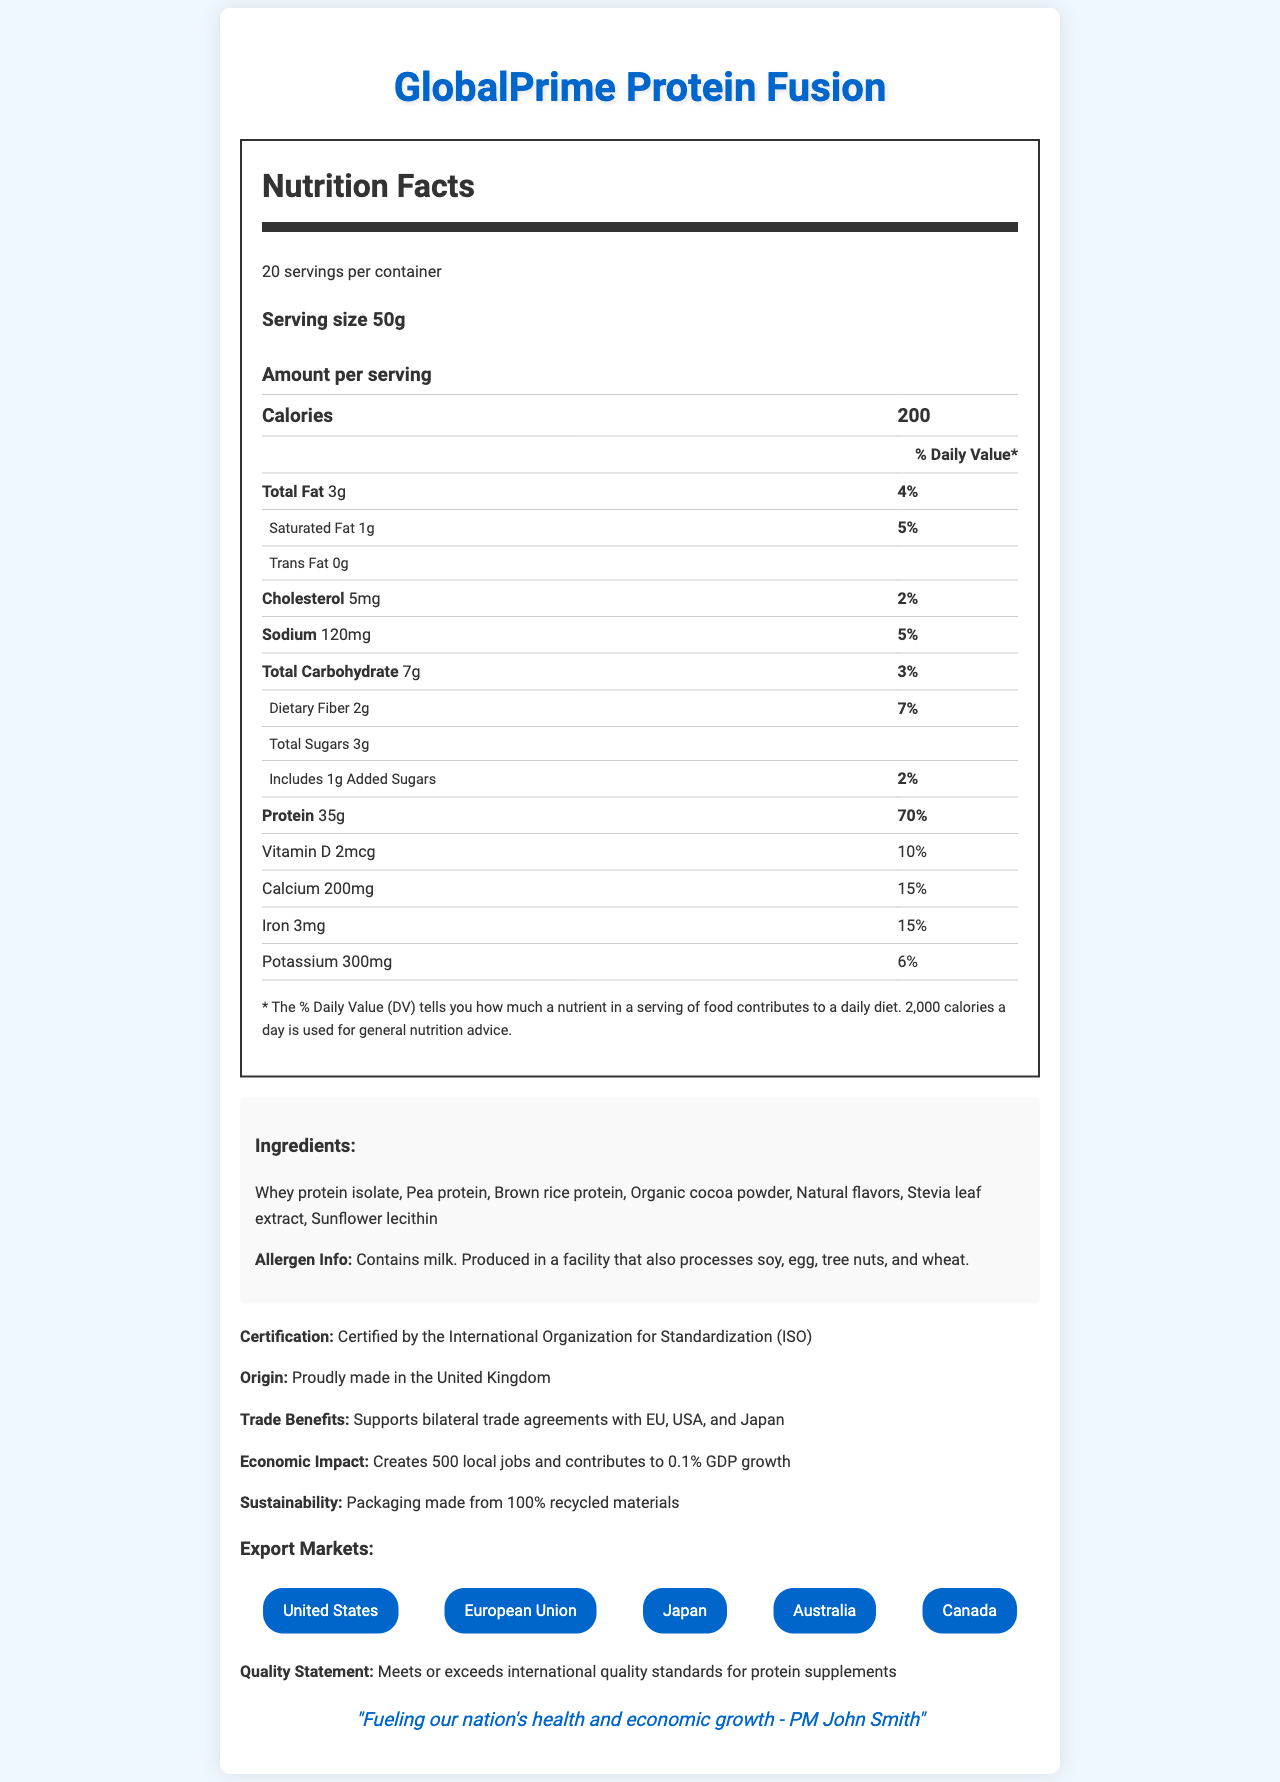describe the main idea of the document The document outlines the nutritional values per serving, ingredients, allergen information, certifications, and export markets. It also emphasizes the product's contribution to local job creation, GDP growth, and sustainability efforts.
Answer: The main idea of the document is to provide detailed nutritional information and benefits of the GlobalPrime Protein Fusion product. It highlights its high protein content, various health benefits, international quality standards, and economic impact, making it appealing to global markets. what is the serving size of GlobalPrime Protein Fusion? The serving size can be found in the section "Amount per serving" and is listed as 50g.
Answer: 50g how many calories are in one serving of GlobalPrime Protein Fusion? The calorie content is prominently displayed in the "Amount per serving" section, stating that one serving contains 200 calories.
Answer: 200 which ingredient in the GlobalPrime Protein Fusion is an allergen? The allergen info section specifies that the product contains milk, which is derived from whey protein isolate.
Answer: Whey protein isolate what is the daily value percentage for protein in one serving? The daily value percentage for protein in one serving is clearly indicated next to the protein amount (35g) under the "Amount per serving" section.
Answer: 70% who endorses the GlobalPrime Protein Fusion? The endorsement is mentioned at the end of the document, stating "Fueling our nation's health and economic growth - PM John Smith".
Answer: Prime Minister John Smith which of the following is NOT a listed export market for GlobalPrime Protein Fusion?
A. United States
B. European Union
C. China
D. Japan The export markets listed include the United States, European Union, Japan, Australia, and Canada. China is not among the mentioned markets.
Answer: C. China how many local jobs does the production of GlobalPrime Protein Fusion create?
A. 100
B. 500
C. 1000
D. 2000 The economic impact section of the document states that the production creates 500 local jobs.
Answer: B. 500 is the packaging of GlobalPrime Protein Fusion sustainable? The sustainability section mentions that the packaging is made from 100% recycled materials, indicating sustainability.
Answer: Yes what is the daily value percentage of calcium in one serving? The daily value percentage of calcium is listed as 15% in the nutrition facts table.
Answer: 15% what is the origin of GlobalPrime Protein Fusion? The product's origin is stated as "Proudly made in the United Kingdom" under the origin section.
Answer: United Kingdom does GlobalPrime Protein Fusion support any bilateral trade agreements? The document states that it supports bilateral trade agreements with the EU, USA, and Japan under the trade benefits section.
Answer: Yes how much dietary fiber is in one serving of GlobalPrime Protein Fusion? The amount of dietary fiber per serving is listed as 2g in the nutrition facts table.
Answer: 2g what organization certified the GlobalPrime Protein Fusion? The certification section states that the product is certified by the International Organization for Standardization (ISO).
Answer: International Organization for Standardization (ISO) how much potassium is in one serving? The amount of potassium per serving is listed as 300mg in the nutrition facts table.
Answer: 300mg what is the economic impact of the GlobalPrime Protein Fusion in terms of GDP growth? The economic impact section states that the product contributes to a 0.1% GDP growth.
Answer: 0.1% how many servings are there per container of GlobalPrime Protein Fusion? The document states there are 20 servings per container.
Answer: 20 how does the GlobalPrime Protein Fusion product contribute to sustainability? The sustainability section mentions that the packaging is made from 100% recycled materials, contributing to sustainability efforts.
Answer: It uses packaging made from 100% recycled materials how much added sugar is in one serving? The amount of added sugars per serving is listed as 1g in the nutrition facts table.
Answer: 1g what is the total carbohydrate content per serving? The total carbohydrate content per serving is listed as 7g in the nutrition facts table.
Answer: 7g how many milligrams of sodium are in one serving? The sodium content per serving is listed as 120mg in the nutrition facts table.
Answer: 120mg which ingredient is used as a sweetener in the GlobalPrime Protein Fusion? The ingredients list includes stevia leaf extract, which is used as a sweetener.
Answer: Stevia leaf extract list the main ingredients of the GlobalPrime Protein Fusion The main ingredients are listed under the ingredients section in the document.
Answer: Whey protein isolate, Pea protein, Brown rice protein, Organic cocoa powder, Natural flavors, Stevia leaf extract, Sunflower lecithin how much iron does one serving contain? The amount of iron per serving is listed as 3mg in the nutrition facts table.
Answer: 3mg what is the level of cholesterol in one serving? The amount of cholesterol per serving is listed as 5mg in the nutrition facts table.
Answer: 5mg what are the total sugars in one serving? The total sugars per serving are listed as 3g in the nutrition facts table.
Answer: 3g is there any trans fat in the GlobalPrime Protein Fusion? The document states the amount of trans fat is 0g, indicating there is no trans fat in the product.
Answer: No what type of protein does GlobalPrime Protein Fusion NOT include? The document lists whey protein isolate, pea protein, and brown rice protein, but it does not state what types of protein are excluded.
Answer: Cannot be determined what percentage of daily value is vitamin D per serving? The daily value percentage of vitamin D per serving is listed as 10% in the nutrition facts table.
Answer: 10% what kind of product is GlobalPrime Protein Fusion? The product description and endorsement emphasize that it is a luxury, high-protein product designed for international markets and to boost trade relations.
Answer: A luxury, high-protein product 